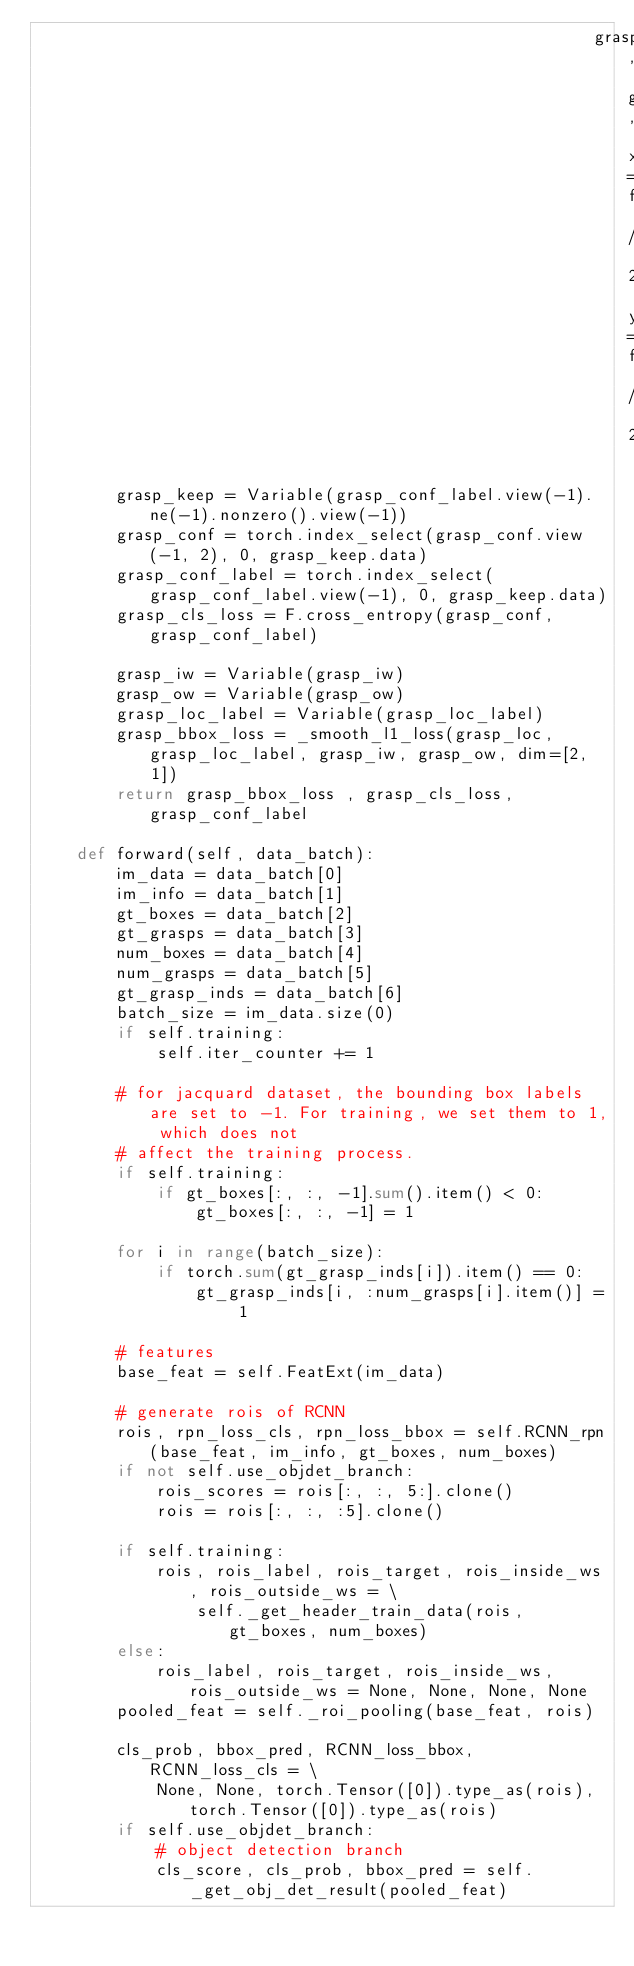<code> <loc_0><loc_0><loc_500><loc_500><_Python_>                                                        grasp_gt, grasp_anchors, xthresh=fsx / 2, ythresh=fsy / 2)

        grasp_keep = Variable(grasp_conf_label.view(-1).ne(-1).nonzero().view(-1))
        grasp_conf = torch.index_select(grasp_conf.view(-1, 2), 0, grasp_keep.data)
        grasp_conf_label = torch.index_select(grasp_conf_label.view(-1), 0, grasp_keep.data)
        grasp_cls_loss = F.cross_entropy(grasp_conf, grasp_conf_label)

        grasp_iw = Variable(grasp_iw)
        grasp_ow = Variable(grasp_ow)
        grasp_loc_label = Variable(grasp_loc_label)
        grasp_bbox_loss = _smooth_l1_loss(grasp_loc, grasp_loc_label, grasp_iw, grasp_ow, dim=[2, 1])
        return grasp_bbox_loss , grasp_cls_loss, grasp_conf_label

    def forward(self, data_batch):
        im_data = data_batch[0]
        im_info = data_batch[1]
        gt_boxes = data_batch[2]
        gt_grasps = data_batch[3]
        num_boxes = data_batch[4]
        num_grasps = data_batch[5]
        gt_grasp_inds = data_batch[6]
        batch_size = im_data.size(0)
        if self.training:
            self.iter_counter += 1

        # for jacquard dataset, the bounding box labels are set to -1. For training, we set them to 1, which does not
        # affect the training process.
        if self.training:
            if gt_boxes[:, :, -1].sum().item() < 0:
                gt_boxes[:, :, -1] = 1

        for i in range(batch_size):
            if torch.sum(gt_grasp_inds[i]).item() == 0:
                gt_grasp_inds[i, :num_grasps[i].item()] = 1

        # features
        base_feat = self.FeatExt(im_data)

        # generate rois of RCNN
        rois, rpn_loss_cls, rpn_loss_bbox = self.RCNN_rpn(base_feat, im_info, gt_boxes, num_boxes)
        if not self.use_objdet_branch:
            rois_scores = rois[:, :, 5:].clone()
            rois = rois[:, :, :5].clone()

        if self.training:
            rois, rois_label, rois_target, rois_inside_ws, rois_outside_ws = \
                self._get_header_train_data(rois, gt_boxes, num_boxes)
        else:
            rois_label, rois_target, rois_inside_ws, rois_outside_ws = None, None, None, None
        pooled_feat = self._roi_pooling(base_feat, rois)

        cls_prob, bbox_pred, RCNN_loss_bbox, RCNN_loss_cls = \
            None, None, torch.Tensor([0]).type_as(rois), torch.Tensor([0]).type_as(rois)
        if self.use_objdet_branch:
            # object detection branch
            cls_score, cls_prob, bbox_pred = self._get_obj_det_result(pooled_feat)</code> 